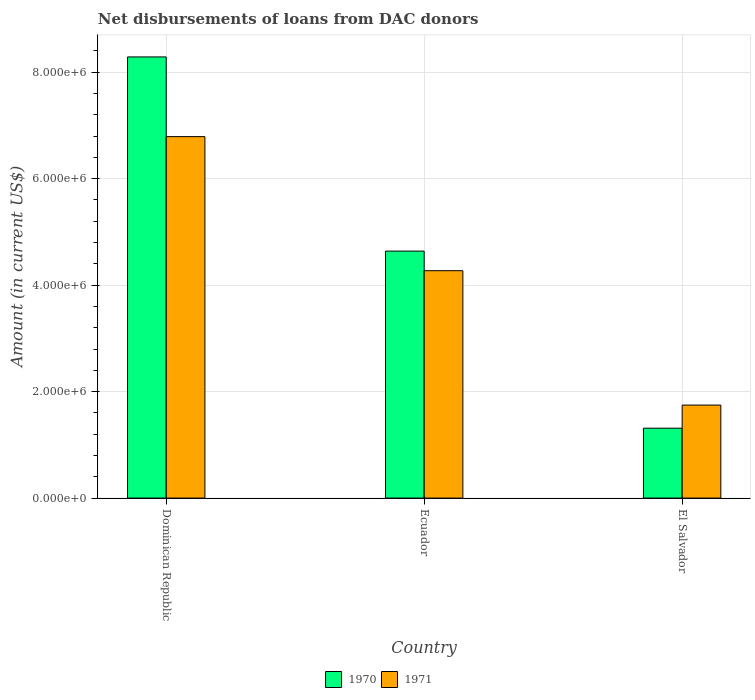Are the number of bars on each tick of the X-axis equal?
Your answer should be very brief. Yes. How many bars are there on the 2nd tick from the right?
Make the answer very short. 2. What is the label of the 1st group of bars from the left?
Provide a succinct answer. Dominican Republic. In how many cases, is the number of bars for a given country not equal to the number of legend labels?
Keep it short and to the point. 0. What is the amount of loans disbursed in 1970 in Dominican Republic?
Keep it short and to the point. 8.29e+06. Across all countries, what is the maximum amount of loans disbursed in 1971?
Offer a terse response. 6.79e+06. Across all countries, what is the minimum amount of loans disbursed in 1971?
Offer a very short reply. 1.75e+06. In which country was the amount of loans disbursed in 1971 maximum?
Your response must be concise. Dominican Republic. In which country was the amount of loans disbursed in 1970 minimum?
Keep it short and to the point. El Salvador. What is the total amount of loans disbursed in 1970 in the graph?
Your answer should be compact. 1.42e+07. What is the difference between the amount of loans disbursed in 1970 in Dominican Republic and that in El Salvador?
Offer a very short reply. 6.97e+06. What is the difference between the amount of loans disbursed in 1970 in El Salvador and the amount of loans disbursed in 1971 in Dominican Republic?
Provide a succinct answer. -5.48e+06. What is the average amount of loans disbursed in 1970 per country?
Your answer should be very brief. 4.75e+06. What is the difference between the amount of loans disbursed of/in 1971 and amount of loans disbursed of/in 1970 in Ecuador?
Your answer should be very brief. -3.68e+05. What is the ratio of the amount of loans disbursed in 1970 in Ecuador to that in El Salvador?
Keep it short and to the point. 3.53. Is the amount of loans disbursed in 1971 in Ecuador less than that in El Salvador?
Your response must be concise. No. What is the difference between the highest and the second highest amount of loans disbursed in 1970?
Your answer should be compact. 3.65e+06. What is the difference between the highest and the lowest amount of loans disbursed in 1971?
Make the answer very short. 5.04e+06. Is the sum of the amount of loans disbursed in 1971 in Dominican Republic and Ecuador greater than the maximum amount of loans disbursed in 1970 across all countries?
Keep it short and to the point. Yes. How many bars are there?
Your answer should be very brief. 6. Are the values on the major ticks of Y-axis written in scientific E-notation?
Ensure brevity in your answer.  Yes. Does the graph contain grids?
Offer a terse response. Yes. How many legend labels are there?
Make the answer very short. 2. How are the legend labels stacked?
Keep it short and to the point. Horizontal. What is the title of the graph?
Your answer should be compact. Net disbursements of loans from DAC donors. What is the Amount (in current US$) of 1970 in Dominican Republic?
Keep it short and to the point. 8.29e+06. What is the Amount (in current US$) of 1971 in Dominican Republic?
Keep it short and to the point. 6.79e+06. What is the Amount (in current US$) in 1970 in Ecuador?
Your answer should be compact. 4.64e+06. What is the Amount (in current US$) of 1971 in Ecuador?
Keep it short and to the point. 4.27e+06. What is the Amount (in current US$) in 1970 in El Salvador?
Keep it short and to the point. 1.31e+06. What is the Amount (in current US$) of 1971 in El Salvador?
Make the answer very short. 1.75e+06. Across all countries, what is the maximum Amount (in current US$) of 1970?
Provide a short and direct response. 8.29e+06. Across all countries, what is the maximum Amount (in current US$) in 1971?
Your response must be concise. 6.79e+06. Across all countries, what is the minimum Amount (in current US$) of 1970?
Offer a very short reply. 1.31e+06. Across all countries, what is the minimum Amount (in current US$) in 1971?
Offer a terse response. 1.75e+06. What is the total Amount (in current US$) of 1970 in the graph?
Offer a terse response. 1.42e+07. What is the total Amount (in current US$) of 1971 in the graph?
Your answer should be very brief. 1.28e+07. What is the difference between the Amount (in current US$) in 1970 in Dominican Republic and that in Ecuador?
Provide a succinct answer. 3.65e+06. What is the difference between the Amount (in current US$) in 1971 in Dominican Republic and that in Ecuador?
Give a very brief answer. 2.52e+06. What is the difference between the Amount (in current US$) of 1970 in Dominican Republic and that in El Salvador?
Your answer should be very brief. 6.97e+06. What is the difference between the Amount (in current US$) of 1971 in Dominican Republic and that in El Salvador?
Offer a very short reply. 5.04e+06. What is the difference between the Amount (in current US$) of 1970 in Ecuador and that in El Salvador?
Your answer should be compact. 3.33e+06. What is the difference between the Amount (in current US$) of 1971 in Ecuador and that in El Salvador?
Offer a very short reply. 2.52e+06. What is the difference between the Amount (in current US$) in 1970 in Dominican Republic and the Amount (in current US$) in 1971 in Ecuador?
Offer a very short reply. 4.02e+06. What is the difference between the Amount (in current US$) in 1970 in Dominican Republic and the Amount (in current US$) in 1971 in El Salvador?
Provide a short and direct response. 6.54e+06. What is the difference between the Amount (in current US$) of 1970 in Ecuador and the Amount (in current US$) of 1971 in El Salvador?
Offer a very short reply. 2.89e+06. What is the average Amount (in current US$) of 1970 per country?
Your answer should be very brief. 4.75e+06. What is the average Amount (in current US$) of 1971 per country?
Your answer should be very brief. 4.27e+06. What is the difference between the Amount (in current US$) in 1970 and Amount (in current US$) in 1971 in Dominican Republic?
Provide a short and direct response. 1.50e+06. What is the difference between the Amount (in current US$) of 1970 and Amount (in current US$) of 1971 in Ecuador?
Offer a terse response. 3.68e+05. What is the difference between the Amount (in current US$) of 1970 and Amount (in current US$) of 1971 in El Salvador?
Offer a terse response. -4.34e+05. What is the ratio of the Amount (in current US$) in 1970 in Dominican Republic to that in Ecuador?
Keep it short and to the point. 1.79. What is the ratio of the Amount (in current US$) in 1971 in Dominican Republic to that in Ecuador?
Your answer should be very brief. 1.59. What is the ratio of the Amount (in current US$) in 1970 in Dominican Republic to that in El Salvador?
Your answer should be very brief. 6.31. What is the ratio of the Amount (in current US$) of 1971 in Dominican Republic to that in El Salvador?
Give a very brief answer. 3.89. What is the ratio of the Amount (in current US$) in 1970 in Ecuador to that in El Salvador?
Provide a short and direct response. 3.53. What is the ratio of the Amount (in current US$) in 1971 in Ecuador to that in El Salvador?
Make the answer very short. 2.44. What is the difference between the highest and the second highest Amount (in current US$) in 1970?
Your answer should be very brief. 3.65e+06. What is the difference between the highest and the second highest Amount (in current US$) of 1971?
Provide a succinct answer. 2.52e+06. What is the difference between the highest and the lowest Amount (in current US$) in 1970?
Keep it short and to the point. 6.97e+06. What is the difference between the highest and the lowest Amount (in current US$) of 1971?
Ensure brevity in your answer.  5.04e+06. 